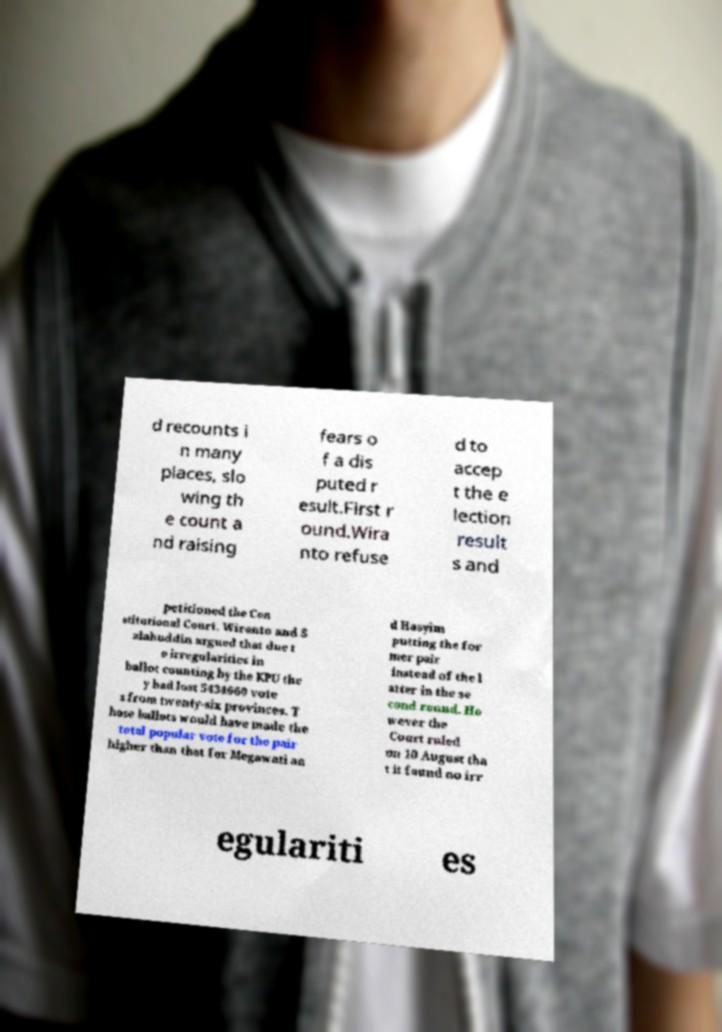What messages or text are displayed in this image? I need them in a readable, typed format. d recounts i n many places, slo wing th e count a nd raising fears o f a dis puted r esult.First r ound.Wira nto refuse d to accep t the e lection result s and petitioned the Con stitutional Court. Wiranto and S alahuddin argued that due t o irregularities in ballot counting by the KPU the y had lost 5434660 vote s from twenty-six provinces. T hose ballots would have made the total popular vote for the pair higher than that for Megawati an d Hasyim putting the for mer pair instead of the l atter in the se cond round. Ho wever the Court ruled on 10 August tha t it found no irr egulariti es 